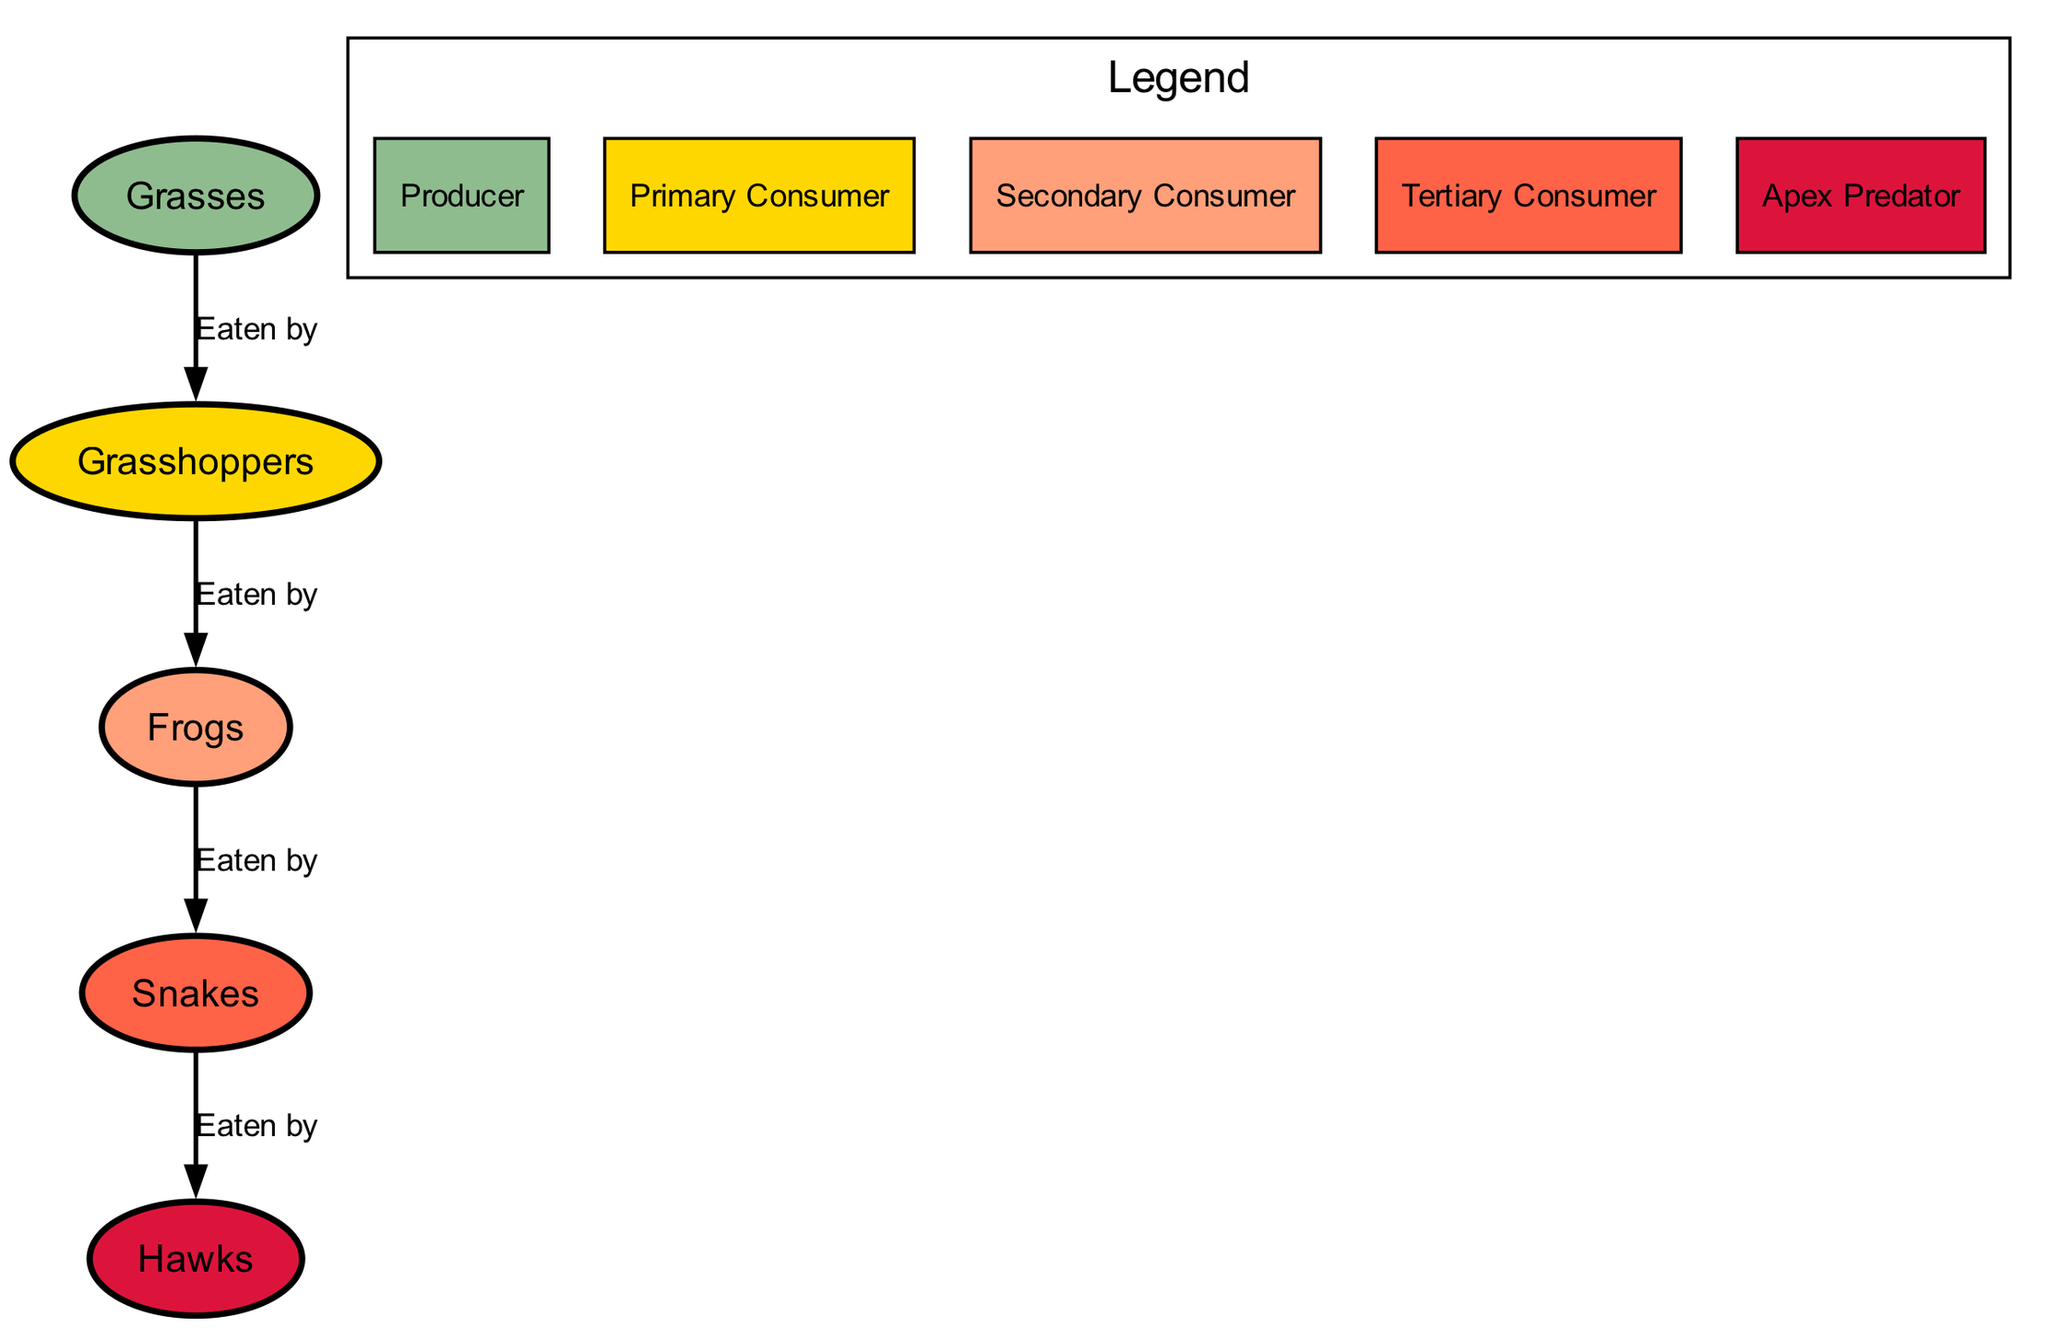What is the top-level consumer in the food chain? The top-level consumer, or apex predator, is identified as "Hawks" in the diagram. This can be determined by tracing the arrows showing the relationships where the "Hawks" are not eaten by any other organisms in the chain.
Answer: Hawks How many primary consumers are present in the diagram? The primary consumers are represented by "Grasshoppers." By counting the nodes designated as primary consumers, we find that there is only one: "Grasshoppers."
Answer: One Which organism is eaten by snakes? The diagram shows that "Frogs" are eaten by "Snakes," as indicated by the arrow connecting their respective nodes, with the label "Eaten by."
Answer: Frogs What is the relationship between grasses and grasshoppers? The relationship is specified by an arrow pointing from "Grasses" to "Grasshoppers," along with the label "Eaten by." This signifies that grasshoppers consume grasses in the food chain.
Answer: Eaten by What is the trend of grasses from time t1 to t4? By examining the time series data from the diagram, "grasses" start at 100 at time t1, decrease to 70 at t3, and then rise to 90 at t4, indicating a fluctuating trend over time. This suggests an initial decline followed by a recovery.
Answer: Fluctuating Explain the change in the number of frogs from time t2 to t3. At time t2, the number of frogs is recorded as 25, and this increases to 30 by time t3. The analysis shows a rise of 5 frogs during this period, indicating an increase in their population.
Answer: Increased by 5 What type of ecological role do grasses play in the food chain? "Grasses" are categorized as a "Producer" in the food chain, which means they generate energy through photosynthesis and form the base of the food chain. This role can be identified by looking at the node type associated with grasses.
Answer: Producer Which organism has the least population at time t1? At time t1, the population is assessed across all organisms, with "Hawks" having a population of 1 compared to others (100 for grasses, 50 for grasshoppers, 20 for frogs, and 5 for snakes). Thus, "Hawks" have the least population.
Answer: Hawks 